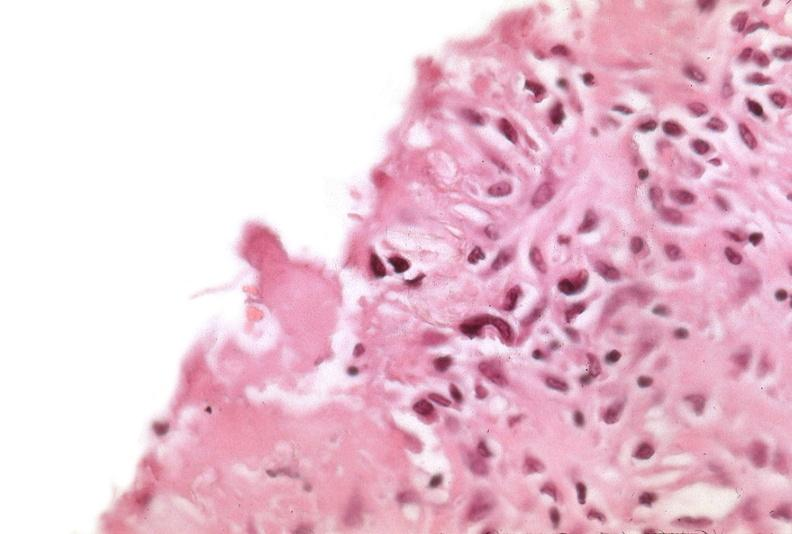s respiratory present?
Answer the question using a single word or phrase. Yes 